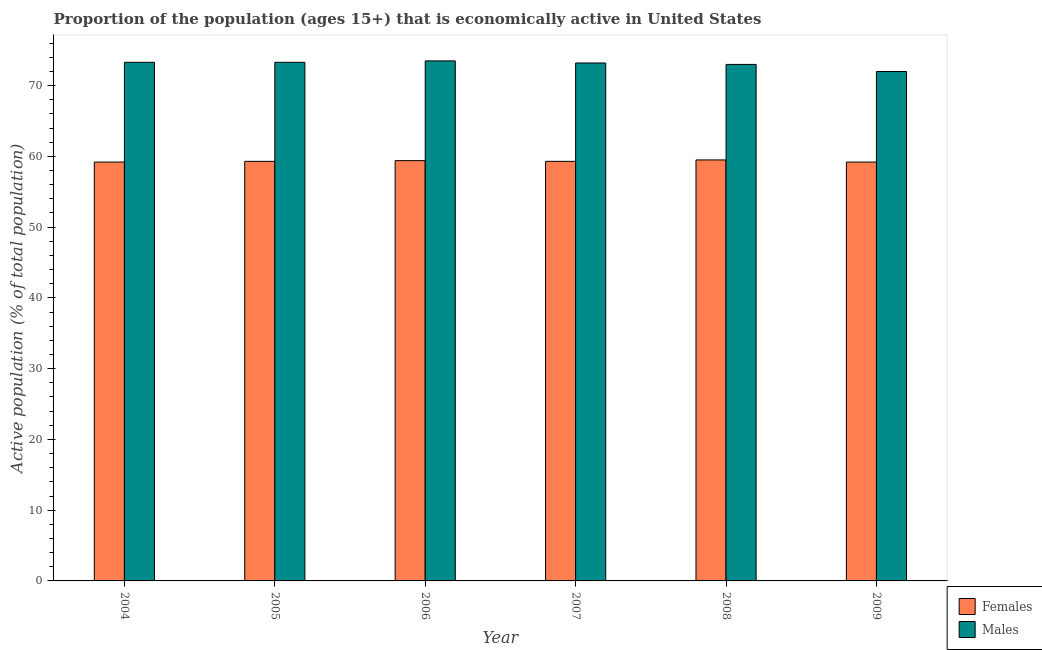How many different coloured bars are there?
Provide a succinct answer. 2. How many groups of bars are there?
Provide a short and direct response. 6. Are the number of bars per tick equal to the number of legend labels?
Provide a succinct answer. Yes. What is the label of the 3rd group of bars from the left?
Offer a very short reply. 2006. What is the percentage of economically active female population in 2007?
Provide a short and direct response. 59.3. Across all years, what is the maximum percentage of economically active male population?
Offer a terse response. 73.5. Across all years, what is the minimum percentage of economically active female population?
Provide a short and direct response. 59.2. In which year was the percentage of economically active male population maximum?
Offer a terse response. 2006. What is the total percentage of economically active female population in the graph?
Your answer should be compact. 355.9. What is the difference between the percentage of economically active female population in 2004 and that in 2006?
Provide a short and direct response. -0.2. What is the difference between the percentage of economically active male population in 2005 and the percentage of economically active female population in 2007?
Offer a terse response. 0.1. What is the average percentage of economically active female population per year?
Offer a very short reply. 59.32. What is the ratio of the percentage of economically active female population in 2005 to that in 2007?
Ensure brevity in your answer.  1. Is the difference between the percentage of economically active male population in 2006 and 2008 greater than the difference between the percentage of economically active female population in 2006 and 2008?
Provide a succinct answer. No. What is the difference between the highest and the second highest percentage of economically active female population?
Your answer should be compact. 0.1. What is the difference between the highest and the lowest percentage of economically active female population?
Keep it short and to the point. 0.3. What does the 2nd bar from the left in 2007 represents?
Offer a very short reply. Males. What does the 1st bar from the right in 2004 represents?
Give a very brief answer. Males. Are all the bars in the graph horizontal?
Your answer should be very brief. No. How many years are there in the graph?
Ensure brevity in your answer.  6. What is the difference between two consecutive major ticks on the Y-axis?
Provide a succinct answer. 10. Are the values on the major ticks of Y-axis written in scientific E-notation?
Keep it short and to the point. No. Does the graph contain any zero values?
Keep it short and to the point. No. Does the graph contain grids?
Your answer should be very brief. No. What is the title of the graph?
Your response must be concise. Proportion of the population (ages 15+) that is economically active in United States. What is the label or title of the Y-axis?
Give a very brief answer. Active population (% of total population). What is the Active population (% of total population) in Females in 2004?
Keep it short and to the point. 59.2. What is the Active population (% of total population) in Males in 2004?
Make the answer very short. 73.3. What is the Active population (% of total population) of Females in 2005?
Keep it short and to the point. 59.3. What is the Active population (% of total population) in Males in 2005?
Provide a short and direct response. 73.3. What is the Active population (% of total population) in Females in 2006?
Offer a very short reply. 59.4. What is the Active population (% of total population) in Males in 2006?
Your answer should be very brief. 73.5. What is the Active population (% of total population) of Females in 2007?
Give a very brief answer. 59.3. What is the Active population (% of total population) in Males in 2007?
Your response must be concise. 73.2. What is the Active population (% of total population) in Females in 2008?
Your response must be concise. 59.5. What is the Active population (% of total population) in Males in 2008?
Give a very brief answer. 73. What is the Active population (% of total population) of Females in 2009?
Provide a succinct answer. 59.2. Across all years, what is the maximum Active population (% of total population) of Females?
Provide a short and direct response. 59.5. Across all years, what is the maximum Active population (% of total population) in Males?
Offer a very short reply. 73.5. Across all years, what is the minimum Active population (% of total population) of Females?
Ensure brevity in your answer.  59.2. What is the total Active population (% of total population) of Females in the graph?
Make the answer very short. 355.9. What is the total Active population (% of total population) of Males in the graph?
Provide a succinct answer. 438.3. What is the difference between the Active population (% of total population) of Females in 2004 and that in 2005?
Keep it short and to the point. -0.1. What is the difference between the Active population (% of total population) of Females in 2004 and that in 2006?
Give a very brief answer. -0.2. What is the difference between the Active population (% of total population) of Males in 2004 and that in 2006?
Provide a short and direct response. -0.2. What is the difference between the Active population (% of total population) in Males in 2004 and that in 2007?
Your answer should be compact. 0.1. What is the difference between the Active population (% of total population) in Males in 2004 and that in 2009?
Provide a succinct answer. 1.3. What is the difference between the Active population (% of total population) of Males in 2005 and that in 2006?
Keep it short and to the point. -0.2. What is the difference between the Active population (% of total population) of Males in 2005 and that in 2007?
Your response must be concise. 0.1. What is the difference between the Active population (% of total population) in Males in 2005 and that in 2008?
Your answer should be compact. 0.3. What is the difference between the Active population (% of total population) of Females in 2005 and that in 2009?
Ensure brevity in your answer.  0.1. What is the difference between the Active population (% of total population) in Males in 2005 and that in 2009?
Make the answer very short. 1.3. What is the difference between the Active population (% of total population) in Females in 2006 and that in 2007?
Provide a short and direct response. 0.1. What is the difference between the Active population (% of total population) in Males in 2006 and that in 2008?
Keep it short and to the point. 0.5. What is the difference between the Active population (% of total population) of Females in 2006 and that in 2009?
Keep it short and to the point. 0.2. What is the difference between the Active population (% of total population) in Females in 2007 and that in 2008?
Make the answer very short. -0.2. What is the difference between the Active population (% of total population) of Males in 2007 and that in 2009?
Your answer should be compact. 1.2. What is the difference between the Active population (% of total population) in Females in 2008 and that in 2009?
Give a very brief answer. 0.3. What is the difference between the Active population (% of total population) of Males in 2008 and that in 2009?
Provide a short and direct response. 1. What is the difference between the Active population (% of total population) in Females in 2004 and the Active population (% of total population) in Males in 2005?
Keep it short and to the point. -14.1. What is the difference between the Active population (% of total population) in Females in 2004 and the Active population (% of total population) in Males in 2006?
Ensure brevity in your answer.  -14.3. What is the difference between the Active population (% of total population) in Females in 2004 and the Active population (% of total population) in Males in 2007?
Make the answer very short. -14. What is the difference between the Active population (% of total population) in Females in 2004 and the Active population (% of total population) in Males in 2008?
Offer a terse response. -13.8. What is the difference between the Active population (% of total population) in Females in 2004 and the Active population (% of total population) in Males in 2009?
Ensure brevity in your answer.  -12.8. What is the difference between the Active population (% of total population) in Females in 2005 and the Active population (% of total population) in Males in 2007?
Offer a terse response. -13.9. What is the difference between the Active population (% of total population) of Females in 2005 and the Active population (% of total population) of Males in 2008?
Provide a short and direct response. -13.7. What is the difference between the Active population (% of total population) of Females in 2007 and the Active population (% of total population) of Males in 2008?
Your response must be concise. -13.7. What is the difference between the Active population (% of total population) of Females in 2007 and the Active population (% of total population) of Males in 2009?
Your answer should be compact. -12.7. What is the average Active population (% of total population) of Females per year?
Your answer should be very brief. 59.32. What is the average Active population (% of total population) of Males per year?
Keep it short and to the point. 73.05. In the year 2004, what is the difference between the Active population (% of total population) in Females and Active population (% of total population) in Males?
Your answer should be very brief. -14.1. In the year 2005, what is the difference between the Active population (% of total population) in Females and Active population (% of total population) in Males?
Make the answer very short. -14. In the year 2006, what is the difference between the Active population (% of total population) of Females and Active population (% of total population) of Males?
Offer a very short reply. -14.1. In the year 2008, what is the difference between the Active population (% of total population) in Females and Active population (% of total population) in Males?
Provide a succinct answer. -13.5. What is the ratio of the Active population (% of total population) in Females in 2004 to that in 2005?
Ensure brevity in your answer.  1. What is the ratio of the Active population (% of total population) of Females in 2004 to that in 2006?
Offer a very short reply. 1. What is the ratio of the Active population (% of total population) of Females in 2004 to that in 2007?
Make the answer very short. 1. What is the ratio of the Active population (% of total population) in Males in 2004 to that in 2007?
Make the answer very short. 1. What is the ratio of the Active population (% of total population) of Females in 2004 to that in 2008?
Offer a terse response. 0.99. What is the ratio of the Active population (% of total population) of Males in 2004 to that in 2008?
Offer a very short reply. 1. What is the ratio of the Active population (% of total population) of Females in 2004 to that in 2009?
Your response must be concise. 1. What is the ratio of the Active population (% of total population) in Males in 2004 to that in 2009?
Keep it short and to the point. 1.02. What is the ratio of the Active population (% of total population) in Males in 2005 to that in 2007?
Make the answer very short. 1. What is the ratio of the Active population (% of total population) in Males in 2005 to that in 2008?
Your answer should be compact. 1. What is the ratio of the Active population (% of total population) in Females in 2005 to that in 2009?
Your answer should be very brief. 1. What is the ratio of the Active population (% of total population) in Males in 2005 to that in 2009?
Offer a very short reply. 1.02. What is the ratio of the Active population (% of total population) of Females in 2006 to that in 2007?
Provide a short and direct response. 1. What is the ratio of the Active population (% of total population) in Males in 2006 to that in 2007?
Make the answer very short. 1. What is the ratio of the Active population (% of total population) of Males in 2006 to that in 2008?
Offer a terse response. 1.01. What is the ratio of the Active population (% of total population) of Males in 2006 to that in 2009?
Your answer should be very brief. 1.02. What is the ratio of the Active population (% of total population) of Females in 2007 to that in 2008?
Ensure brevity in your answer.  1. What is the ratio of the Active population (% of total population) in Males in 2007 to that in 2008?
Provide a short and direct response. 1. What is the ratio of the Active population (% of total population) of Males in 2007 to that in 2009?
Make the answer very short. 1.02. What is the ratio of the Active population (% of total population) of Females in 2008 to that in 2009?
Offer a terse response. 1.01. What is the ratio of the Active population (% of total population) in Males in 2008 to that in 2009?
Ensure brevity in your answer.  1.01. What is the difference between the highest and the second highest Active population (% of total population) in Females?
Make the answer very short. 0.1. 